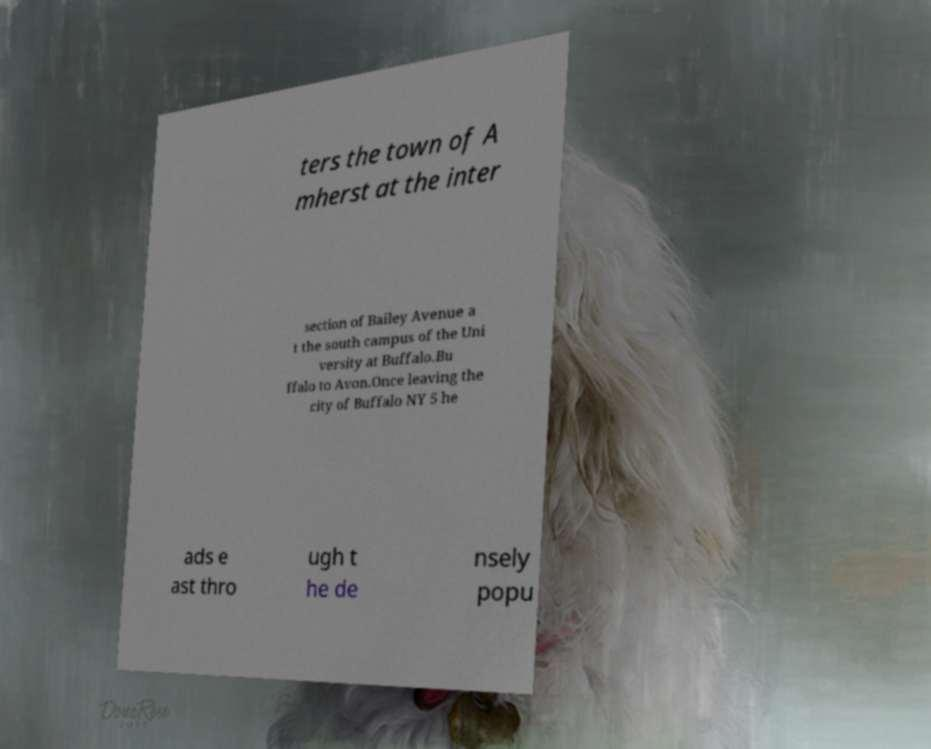For documentation purposes, I need the text within this image transcribed. Could you provide that? ters the town of A mherst at the inter section of Bailey Avenue a t the south campus of the Uni versity at Buffalo.Bu ffalo to Avon.Once leaving the city of Buffalo NY 5 he ads e ast thro ugh t he de nsely popu 